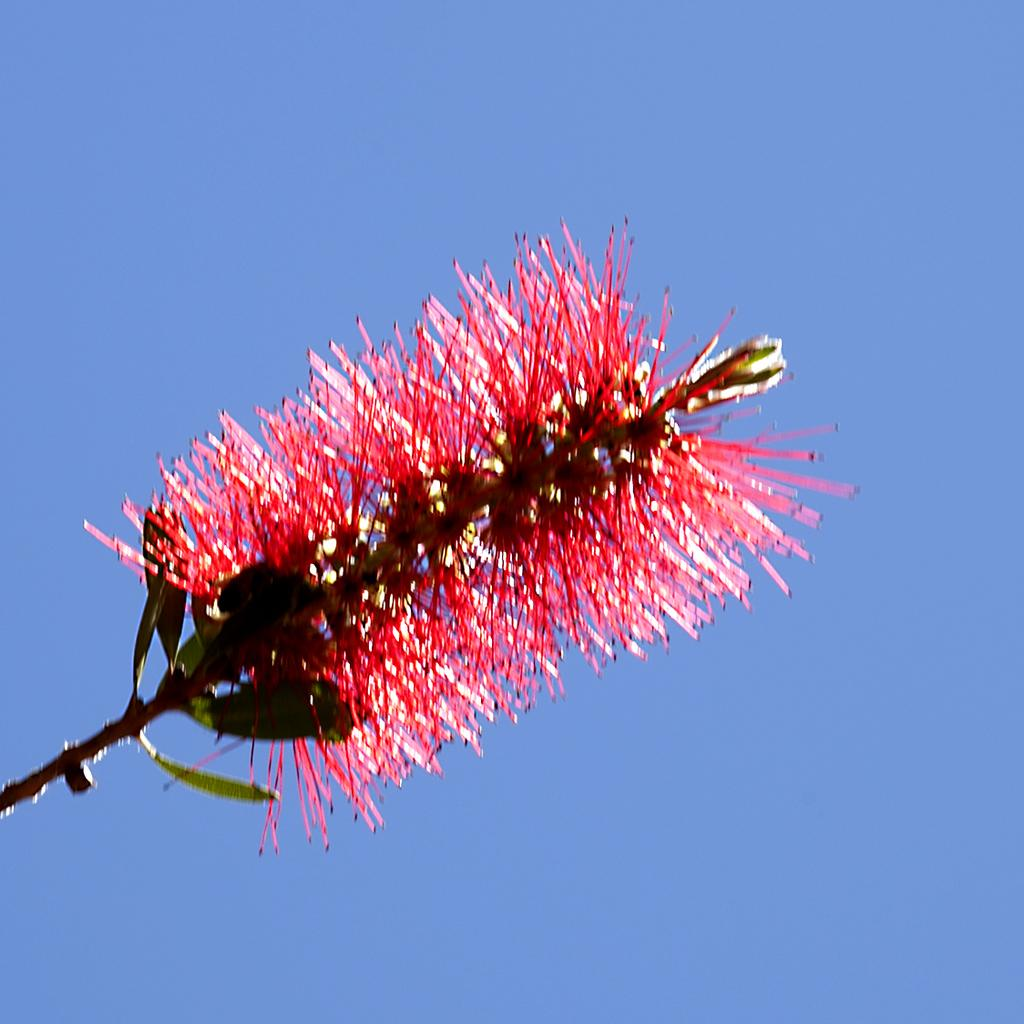Where was the image taken? The image is taken outdoors. What can be seen in the background of the image? There is the sky visible in the background. What is the main subject of the image? There is a stem of a plant in the middle of the image. What are the characteristics of the plant? The plant has green leaves and a red colored flower. What is the weight of the writing on the plant in the image? There is no writing present on the plant in the image, so there is no weight to consider. 